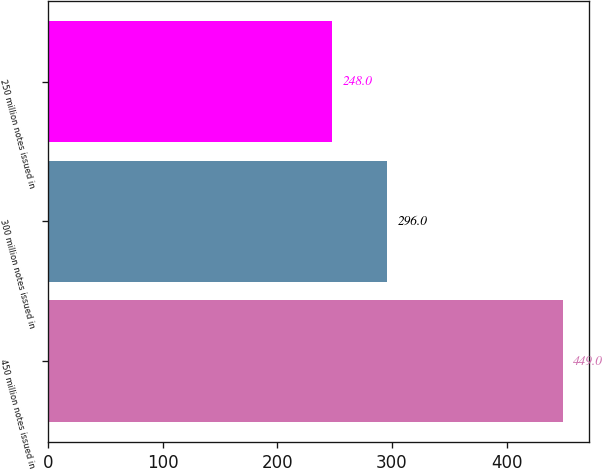Convert chart. <chart><loc_0><loc_0><loc_500><loc_500><bar_chart><fcel>450 million notes issued in<fcel>300 million notes issued in<fcel>250 million notes issued in<nl><fcel>449<fcel>296<fcel>248<nl></chart> 